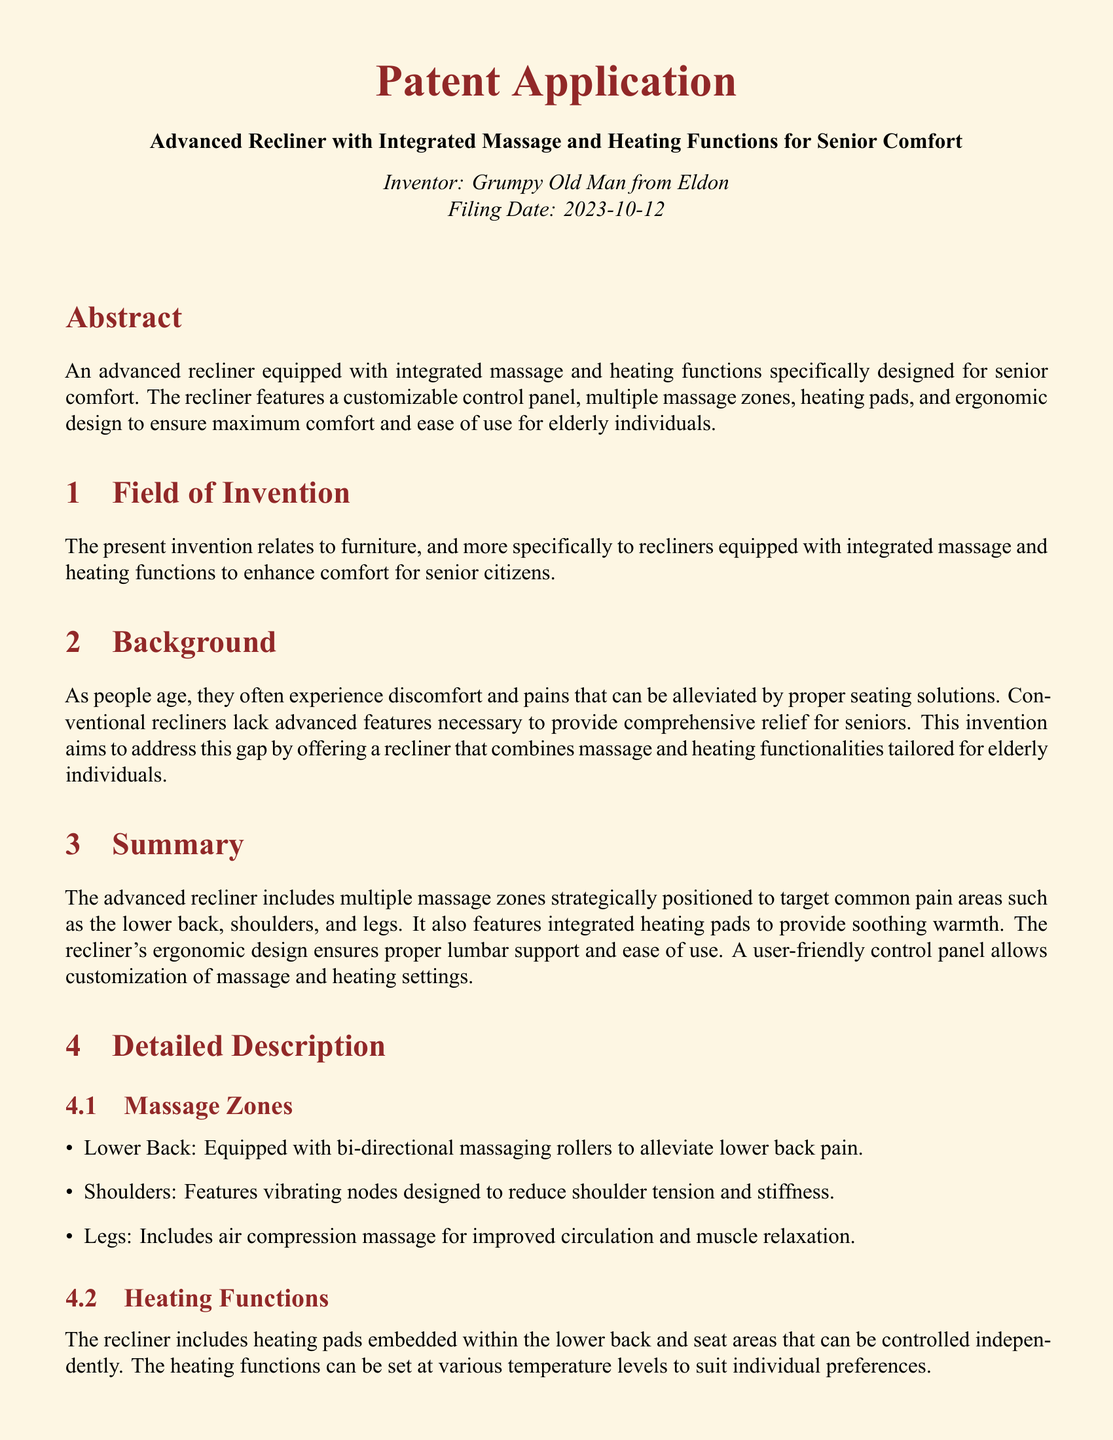What is the title of the invention? The title of the invention is stated clearly at the beginning of the document, which is "Advanced Recliner with Integrated Massage and Heating Functions for Senior Comfort."
Answer: Advanced Recliner with Integrated Massage and Heating Functions for Senior Comfort Who is the inventor? The inventor's name is mentioned in the document's header, identifying the individual behind the invention.
Answer: Grumpy Old Man from Eldon What date was the application filed? The filing date of the patent application is specified within the document, providing a clear reference point.
Answer: 2023-10-12 What are the three main pain areas targeted by the massage zones? The document lists the specific areas on the body that the massage zones are designed to alleviate pain from.
Answer: Lower back, shoulders, and legs What type of heating functions does the recliner include? The document provides details on the heating features embedded within the recliner, outlining the components included.
Answer: Heating pads How many claims are in the patent application? The number of claims is easily countable based on the claims section of the document, indicating the scope of protection sought.
Answer: Eight What is the primary purpose of the recliner? The document explains the main goal of the invention and its intended users.
Answer: Enhance comfort for senior citizens What feature of the control panel aids elderly users? The document highlights specific design elements of the control panel that accommodate the needs of its target demographic.
Answer: Large buttons and clear labels 